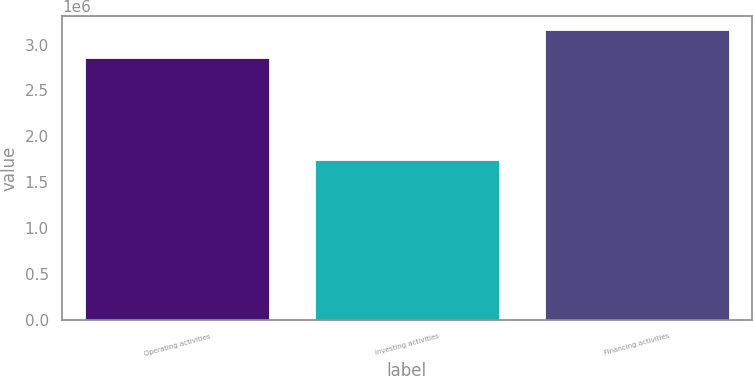Convert chart. <chart><loc_0><loc_0><loc_500><loc_500><bar_chart><fcel>Operating activities<fcel>Investing activities<fcel>Financing activities<nl><fcel>2.85425e+06<fcel>1.73707e+06<fcel>3.15393e+06<nl></chart> 